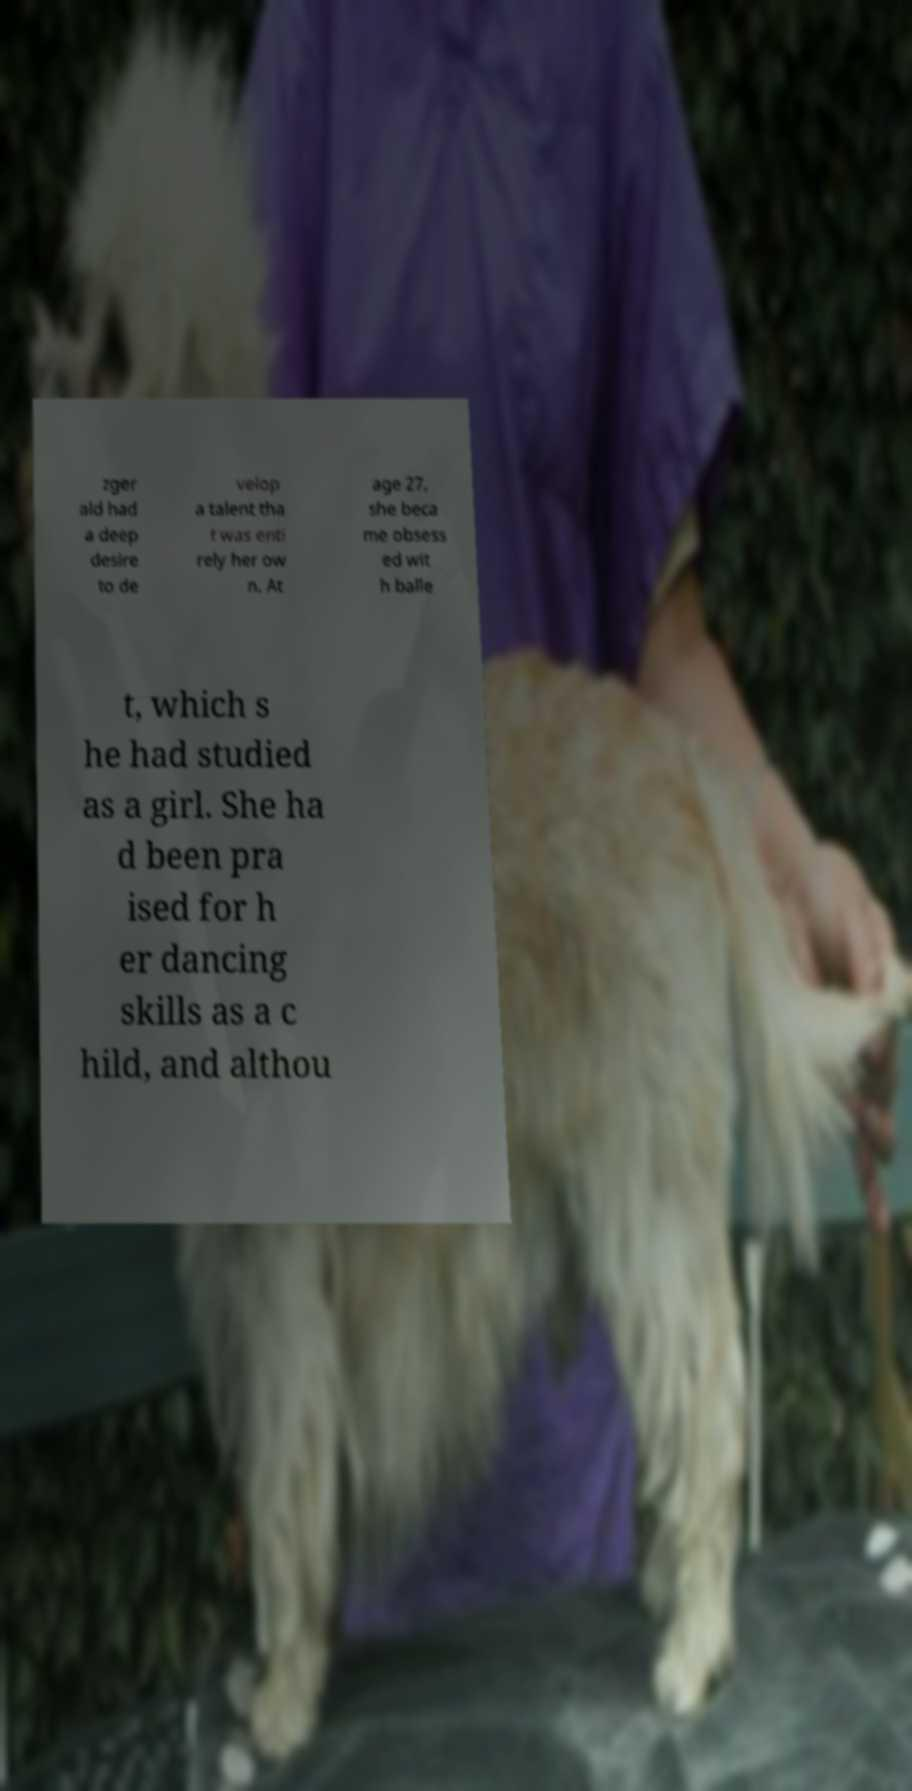Can you accurately transcribe the text from the provided image for me? zger ald had a deep desire to de velop a talent tha t was enti rely her ow n. At age 27, she beca me obsess ed wit h balle t, which s he had studied as a girl. She ha d been pra ised for h er dancing skills as a c hild, and althou 